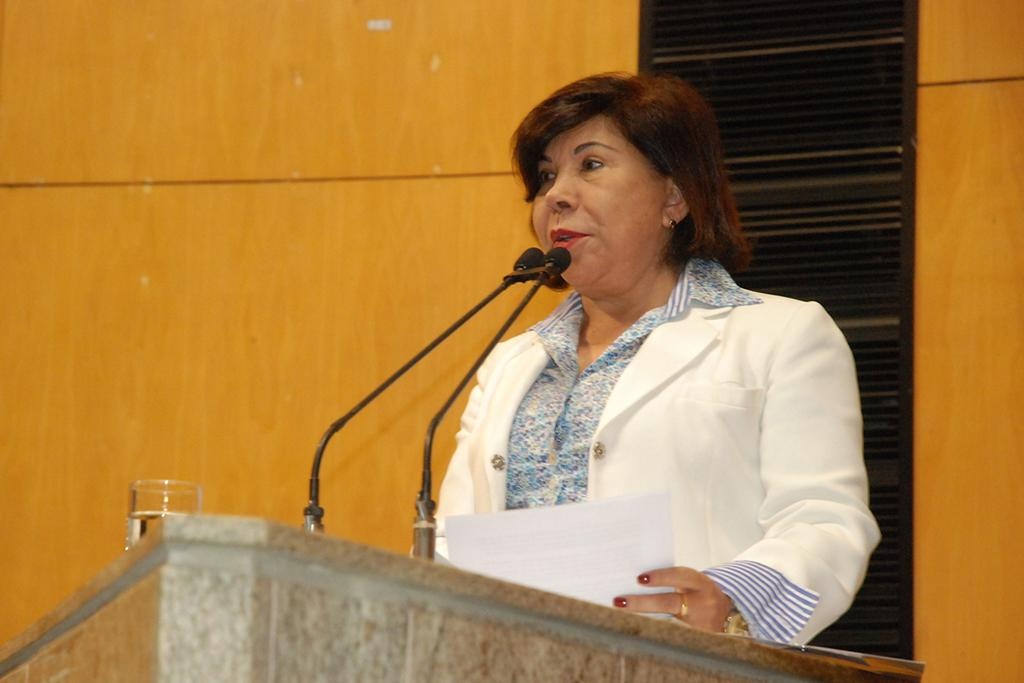Who is the main subject in the foreground of the image? There is a woman in the foreground of the image. What is the woman doing in the image? The woman is standing in front of a microphone. What is located in the foreground of the image besides the woman? There is a table in the foreground of the image. What can be seen in the background of the image? There is a wall and a door in the background of the image. What type of location might the image have been taken in? The image may have been taken in a hall. What type of seed can be seen growing on the woman's face in the image? There is no seed growing on the woman's face in the image. How does the ant contribute to the scene in the image? There are no ants present in the image. 